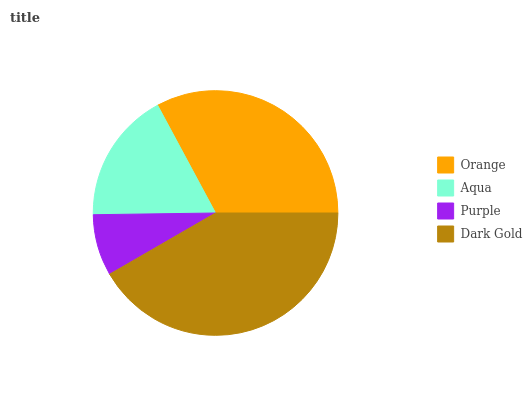Is Purple the minimum?
Answer yes or no. Yes. Is Dark Gold the maximum?
Answer yes or no. Yes. Is Aqua the minimum?
Answer yes or no. No. Is Aqua the maximum?
Answer yes or no. No. Is Orange greater than Aqua?
Answer yes or no. Yes. Is Aqua less than Orange?
Answer yes or no. Yes. Is Aqua greater than Orange?
Answer yes or no. No. Is Orange less than Aqua?
Answer yes or no. No. Is Orange the high median?
Answer yes or no. Yes. Is Aqua the low median?
Answer yes or no. Yes. Is Purple the high median?
Answer yes or no. No. Is Dark Gold the low median?
Answer yes or no. No. 